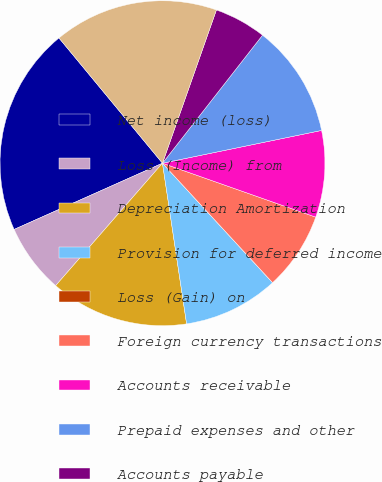<chart> <loc_0><loc_0><loc_500><loc_500><pie_chart><fcel>Net income (loss)<fcel>Loss (Income) from<fcel>Depreciation Amortization<fcel>Provision for deferred income<fcel>Loss (Gain) on<fcel>Foreign currency transactions<fcel>Accounts receivable<fcel>Prepaid expenses and other<fcel>Accounts payable<fcel>Accrued expenses deferred<nl><fcel>20.69%<fcel>6.9%<fcel>13.79%<fcel>9.48%<fcel>0.0%<fcel>7.76%<fcel>8.62%<fcel>11.21%<fcel>5.17%<fcel>16.38%<nl></chart> 